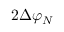Convert formula to latex. <formula><loc_0><loc_0><loc_500><loc_500>2 \Delta { { \varphi } _ { N } }</formula> 